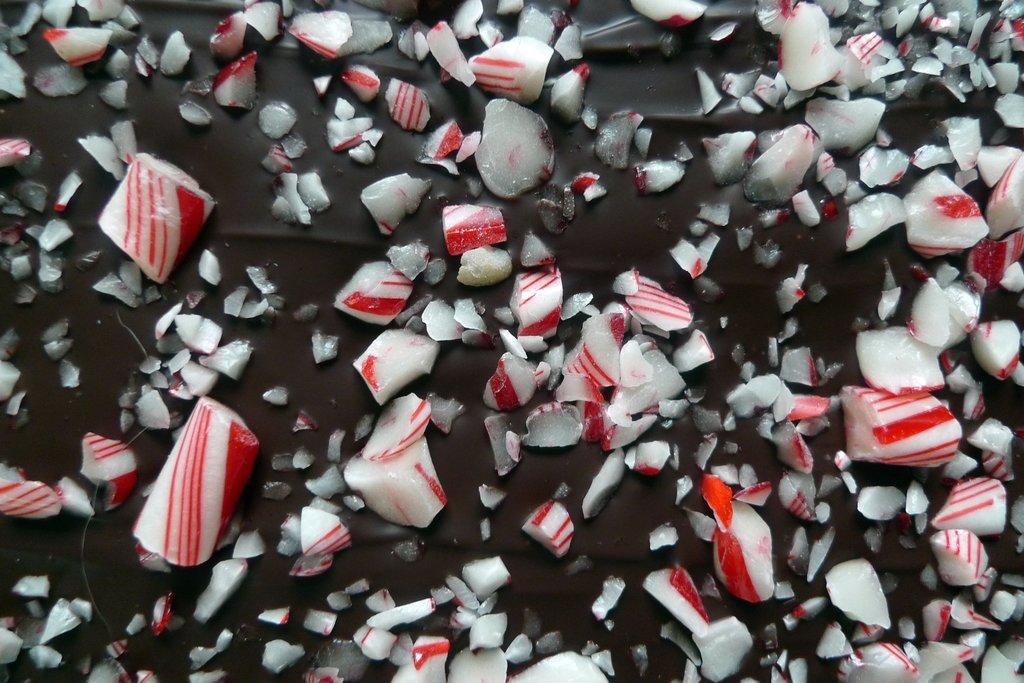What is the main subject of the image? The main subject of the image is a chocolate. What is placed on top of the chocolate? There are pieces of candy over the chocolate in the image. What suggestion does the chocolate make to the ducks in the image? There are no ducks present in the image, and therefore no such interaction can be observed. 